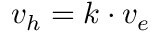Convert formula to latex. <formula><loc_0><loc_0><loc_500><loc_500>v _ { h } = k \cdot v _ { e }</formula> 